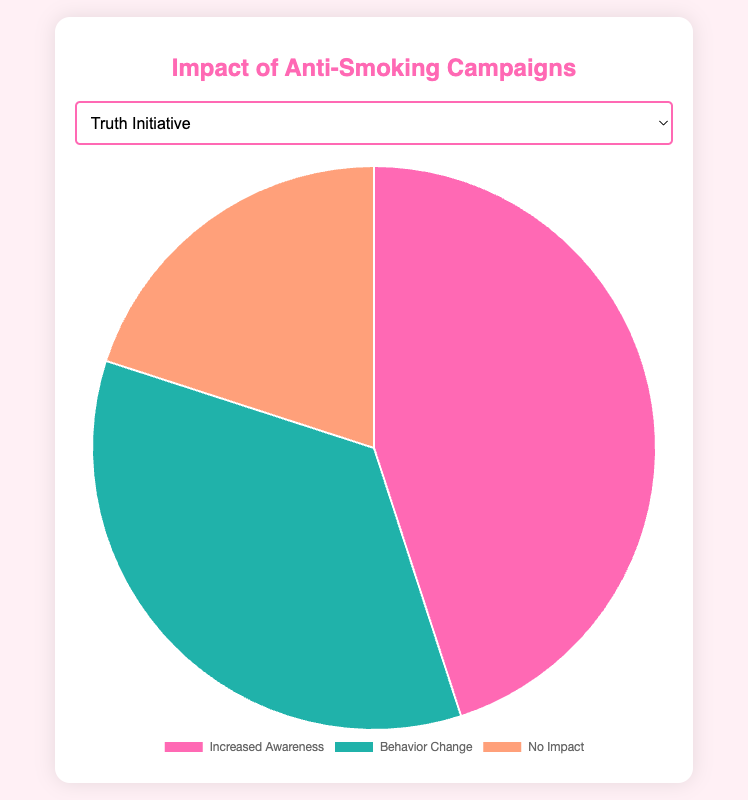Which campaign has the highest percentage of 'Increased Awareness'? Looking at the 'Increased Awareness' data points, Anti-Smoking Bollywood Movie 'No Smoking' has the highest percentage at 60.
Answer: Anti-Smoking Bollywood Movie 'No Smoking' What is the combined percentage of 'Behavior Change' for the WHO No Tobacco Day and FDA Real Cost campaigns? The percentage of 'Behavior Change' for WHO No Tobacco Day is 25 and for FDA Real Cost is 25. Summing these, 25 + 25 = 50.
Answer: 50 Which campaign shows the lowest percentage of 'No Impact'? By examining the 'No Impact' percentages, both Truth Initiative, CDC Tips From Former Smokers, Anti-Smoking Bollywood Movie 'No Smoking', and FDA Real Cost have the lowest percentage at 20.
Answer: Truth Initiative, CDC Tips From Former Smokers, Anti-Smoking Bollywood Movie 'No Smoking', FDA Real Cost What is the difference between 'Increased Awareness' and 'No Impact' for the CDC Tips From Former Smokers campaign? The percentage of 'Increased Awareness' for CDC Tips From Former Smokers is 50 and 'No Impact' is 20. The difference is 50 - 20 = 30.
Answer: 30 How much higher is the 'Increased Awareness' percentage in Anti-Smoking Bollywood Movie 'No Smoking' compared to WHO No Tobacco Day? Anti-Smoking Bollywood Movie 'No Smoking' has an 'Increased Awareness' percentage of 60, while WHO No Tobacco Day has 40. The difference is 60 - 40 = 20.
Answer: 20 Which color in the pie chart represents 'Behavior Change'? The color associated with 'Behavior Change' in the pie chart is teal.
Answer: Teal 